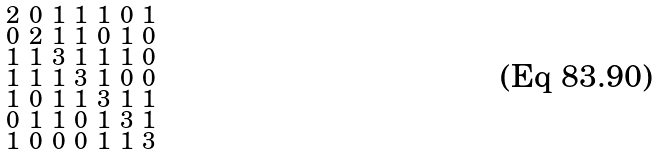Convert formula to latex. <formula><loc_0><loc_0><loc_500><loc_500>\begin{smallmatrix} 2 & 0 & 1 & 1 & 1 & 0 & 1 \\ 0 & 2 & 1 & 1 & 0 & 1 & 0 \\ 1 & 1 & 3 & 1 & 1 & 1 & 0 \\ 1 & 1 & 1 & 3 & 1 & 0 & 0 \\ 1 & 0 & 1 & 1 & 3 & 1 & 1 \\ 0 & 1 & 1 & 0 & 1 & 3 & 1 \\ 1 & 0 & 0 & 0 & 1 & 1 & 3 \end{smallmatrix}</formula> 